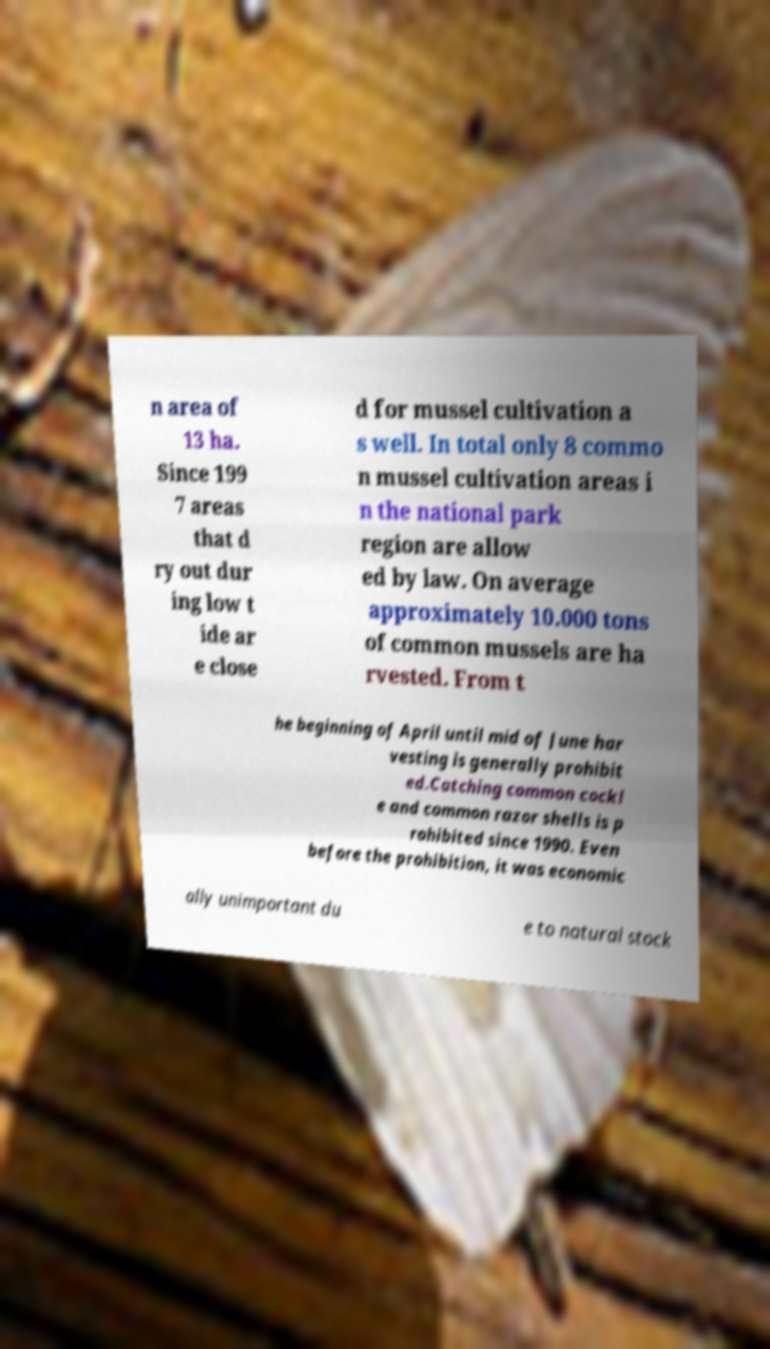Could you assist in decoding the text presented in this image and type it out clearly? n area of 13 ha. Since 199 7 areas that d ry out dur ing low t ide ar e close d for mussel cultivation a s well. In total only 8 commo n mussel cultivation areas i n the national park region are allow ed by law. On average approximately 10.000 tons of common mussels are ha rvested. From t he beginning of April until mid of June har vesting is generally prohibit ed.Catching common cockl e and common razor shells is p rohibited since 1990. Even before the prohibition, it was economic ally unimportant du e to natural stock 